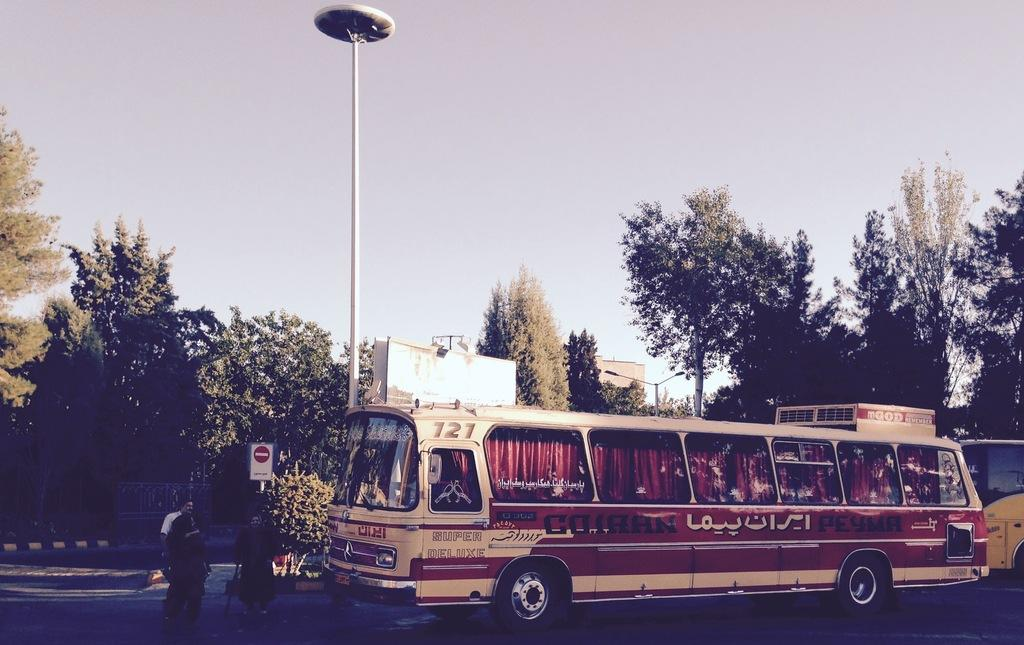<image>
Present a compact description of the photo's key features. a bus that has the numbers 127 on it 